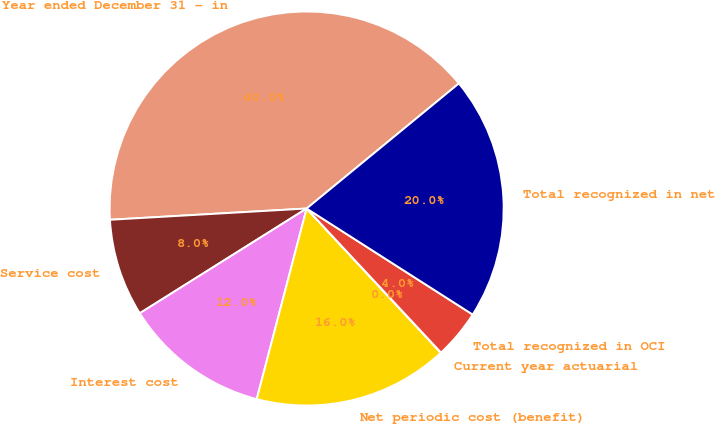<chart> <loc_0><loc_0><loc_500><loc_500><pie_chart><fcel>Year ended December 31 - in<fcel>Service cost<fcel>Interest cost<fcel>Net periodic cost (benefit)<fcel>Current year actuarial<fcel>Total recognized in OCI<fcel>Total recognized in net<nl><fcel>39.96%<fcel>8.01%<fcel>12.0%<fcel>16.0%<fcel>0.02%<fcel>4.01%<fcel>19.99%<nl></chart> 